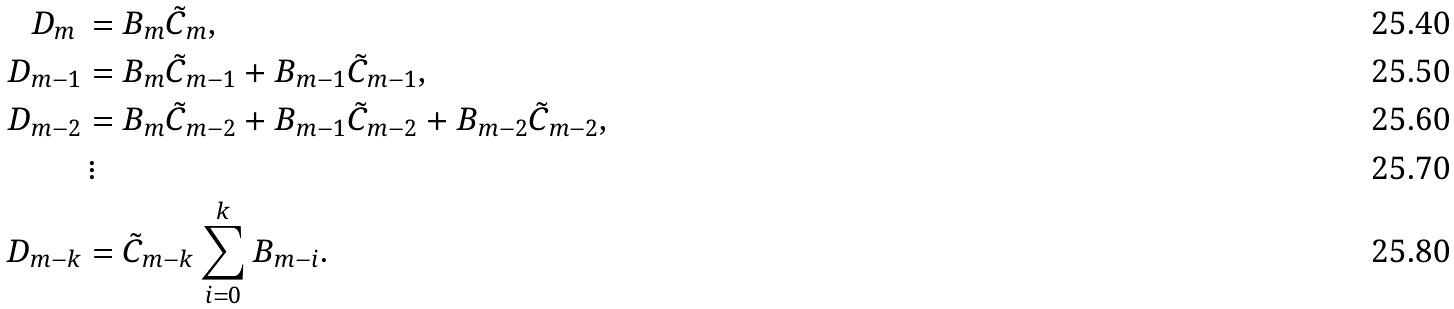Convert formula to latex. <formula><loc_0><loc_0><loc_500><loc_500>D _ { m } \, & = B _ { m } \tilde { C } _ { m } , \\ D _ { m - 1 } & = B _ { m } \tilde { C } _ { m - 1 } + B _ { m - 1 } \tilde { C } _ { m - 1 } , \\ D _ { m - 2 } & = B _ { m } \tilde { C } _ { m - 2 } + B _ { m - 1 } \tilde { C } _ { m - 2 } + B _ { m - 2 } \tilde { C } _ { m - 2 } , \\ & \, \vdots \\ D _ { m - k } & = \tilde { C } _ { m - k } \sum _ { i = 0 } ^ { k } B _ { m - i } .</formula> 